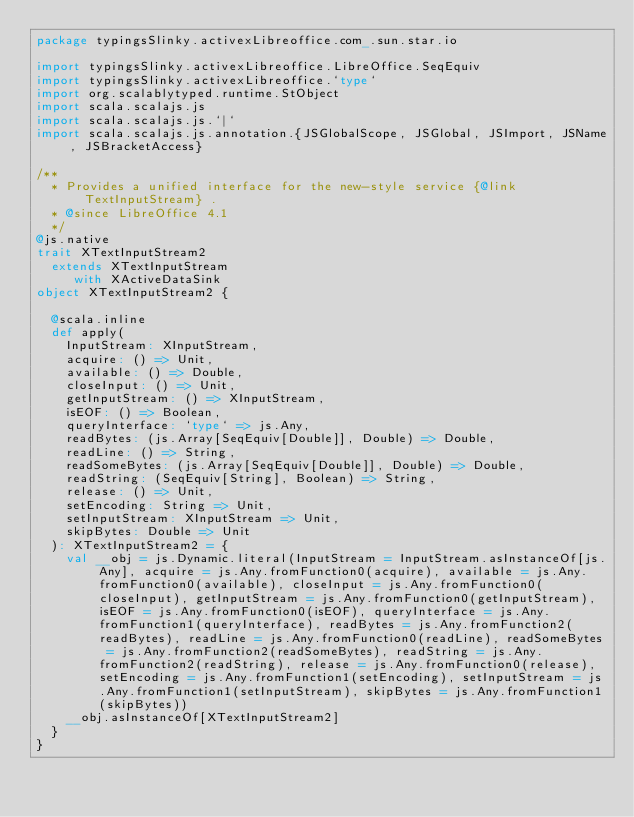<code> <loc_0><loc_0><loc_500><loc_500><_Scala_>package typingsSlinky.activexLibreoffice.com_.sun.star.io

import typingsSlinky.activexLibreoffice.LibreOffice.SeqEquiv
import typingsSlinky.activexLibreoffice.`type`
import org.scalablytyped.runtime.StObject
import scala.scalajs.js
import scala.scalajs.js.`|`
import scala.scalajs.js.annotation.{JSGlobalScope, JSGlobal, JSImport, JSName, JSBracketAccess}

/**
  * Provides a unified interface for the new-style service {@link TextInputStream} .
  * @since LibreOffice 4.1
  */
@js.native
trait XTextInputStream2
  extends XTextInputStream
     with XActiveDataSink
object XTextInputStream2 {
  
  @scala.inline
  def apply(
    InputStream: XInputStream,
    acquire: () => Unit,
    available: () => Double,
    closeInput: () => Unit,
    getInputStream: () => XInputStream,
    isEOF: () => Boolean,
    queryInterface: `type` => js.Any,
    readBytes: (js.Array[SeqEquiv[Double]], Double) => Double,
    readLine: () => String,
    readSomeBytes: (js.Array[SeqEquiv[Double]], Double) => Double,
    readString: (SeqEquiv[String], Boolean) => String,
    release: () => Unit,
    setEncoding: String => Unit,
    setInputStream: XInputStream => Unit,
    skipBytes: Double => Unit
  ): XTextInputStream2 = {
    val __obj = js.Dynamic.literal(InputStream = InputStream.asInstanceOf[js.Any], acquire = js.Any.fromFunction0(acquire), available = js.Any.fromFunction0(available), closeInput = js.Any.fromFunction0(closeInput), getInputStream = js.Any.fromFunction0(getInputStream), isEOF = js.Any.fromFunction0(isEOF), queryInterface = js.Any.fromFunction1(queryInterface), readBytes = js.Any.fromFunction2(readBytes), readLine = js.Any.fromFunction0(readLine), readSomeBytes = js.Any.fromFunction2(readSomeBytes), readString = js.Any.fromFunction2(readString), release = js.Any.fromFunction0(release), setEncoding = js.Any.fromFunction1(setEncoding), setInputStream = js.Any.fromFunction1(setInputStream), skipBytes = js.Any.fromFunction1(skipBytes))
    __obj.asInstanceOf[XTextInputStream2]
  }
}
</code> 